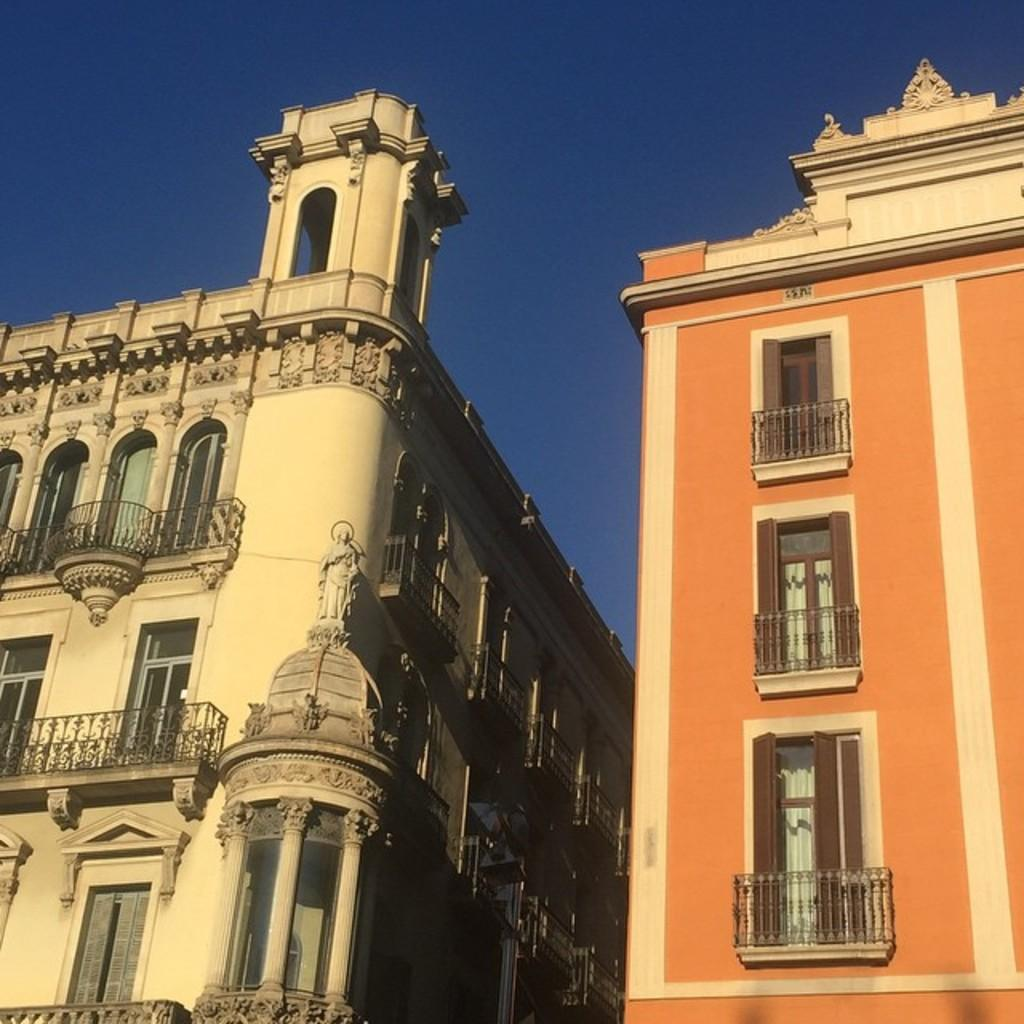What type of structures are visible in the image? There are buildings with windows in the image. What color is the sky in the image? The sky is blue in the image. How many tomatoes are hanging from the skirt in the image? There is no skirt or tomatoes present in the image. 